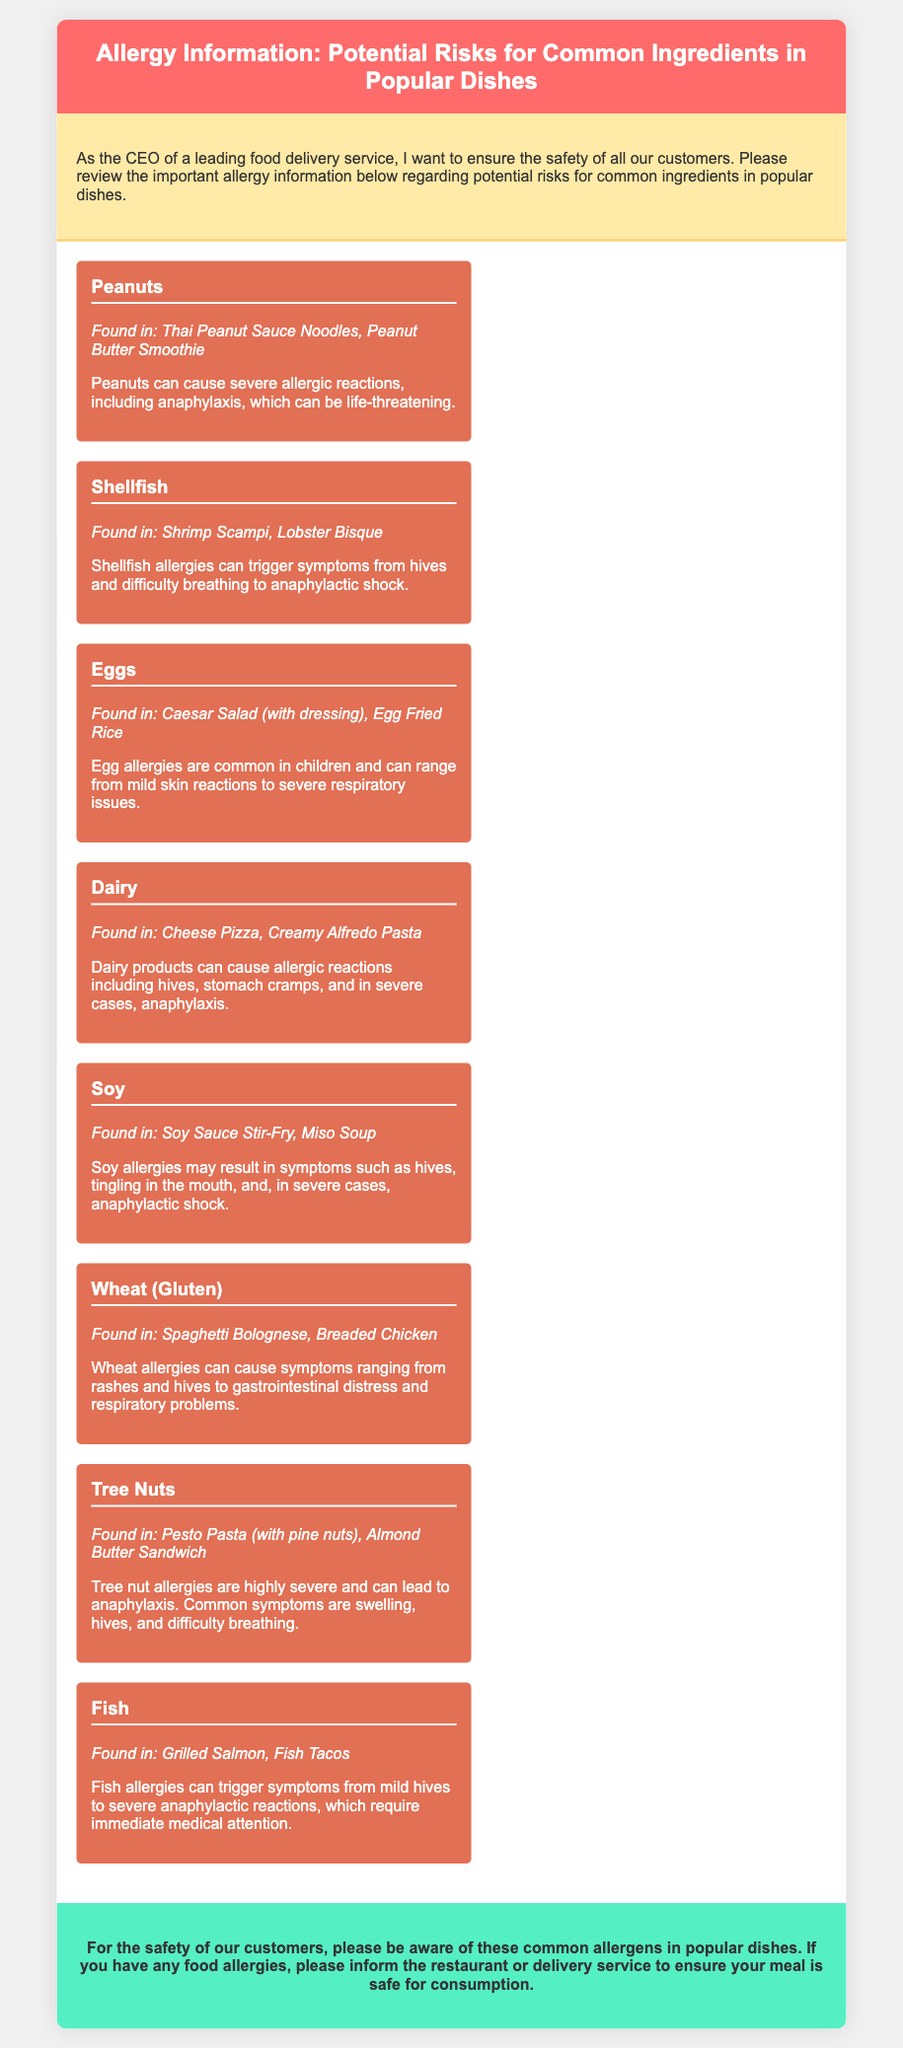What are the common allergens mentioned? The document lists specific allergens such as Peanuts, Shellfish, and Eggs, among others.
Answer: Peanuts, Shellfish, Eggs, Dairy, Soy, Wheat, Tree Nuts, Fish How many dishes contain the ingredient 'Dairy'? The document specifies that Dairy is found in Cheese Pizza and Creamy Alfredo Pasta, totaling two dishes.
Answer: 2 What serious reaction can Peanuts cause? The document explicitly states that Peanuts can cause severe allergic reactions, including anaphylaxis.
Answer: Anaphylaxis Which ingredient is associated with the dish 'Fish Tacos'? The document indicates that Fish is the ingredient found in Fish Tacos.
Answer: Fish What is the allergy risk associated with Shellfish? The information notes that Shellfish allergies can trigger symptoms from hives and difficulty breathing to anaphylactic shock.
Answer: Anaphylactic shock How many total allergenic ingredients are listed? The document provides information about eight different allergenic ingredients.
Answer: 8 Which ingredient is commonly found in Caesar Salad? The document states that Eggs are found in Caesar Salad (with dressing).
Answer: Eggs What common symptoms are associated with a Tree Nut allergy? The document notes that tree nut allergies can lead to symptoms such as swelling, hives, and difficulty breathing.
Answer: Swelling, hives, difficulty breathing 